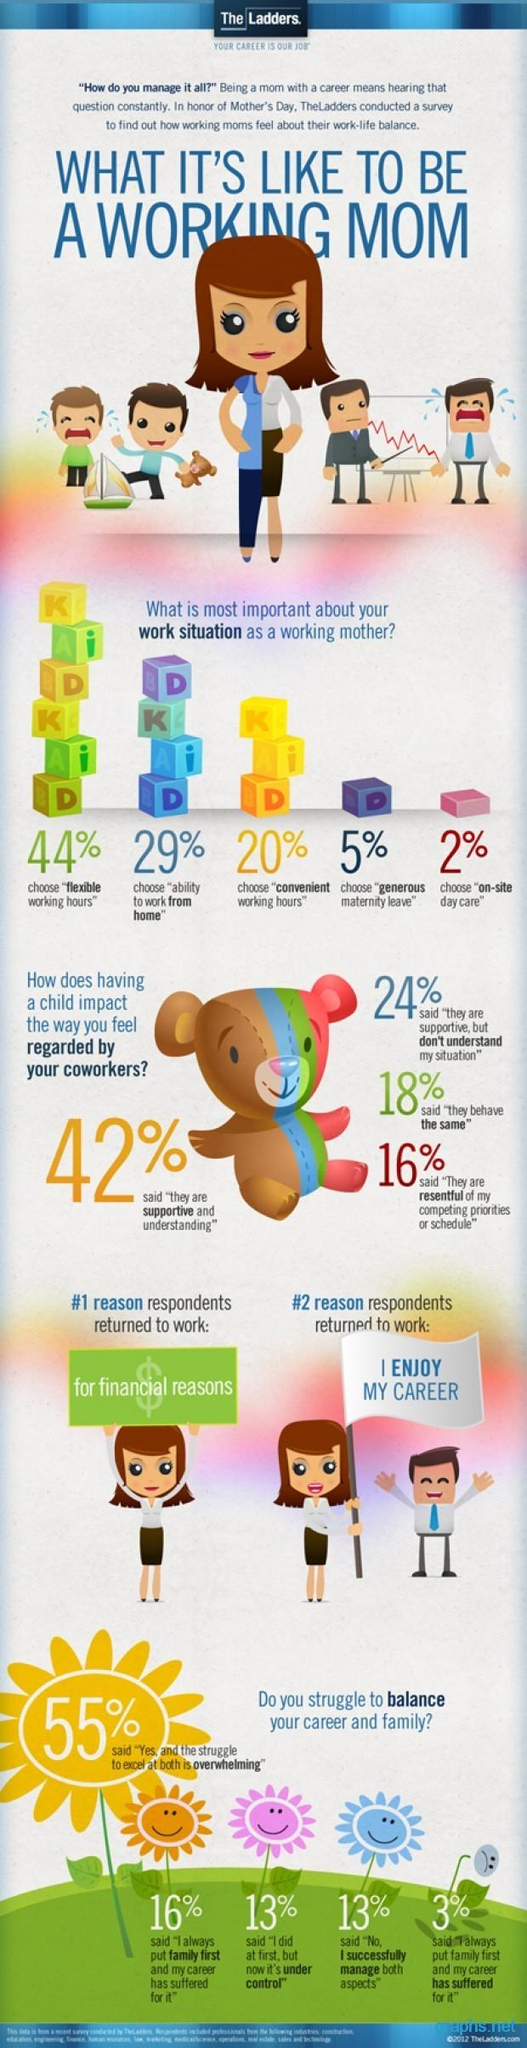Mention a couple of crucial points in this snapshot. According to the given options, 16% of colleagues are displeased with the family priorities that occur after childbirth. According to a recent survey, 29% of moms choose to work from home. According to the survey, 16% of respondents believe that their career has been negatively impacted by prioritizing their family, while only 3% feel that their career has been positively impacted in the same way. Out of all respondents, 7% chose to have generous maternity leave and on-site day care. According to the given data, 42% of women find it challenging to balance their career and family life, while 58% of women are able to excel at both. 